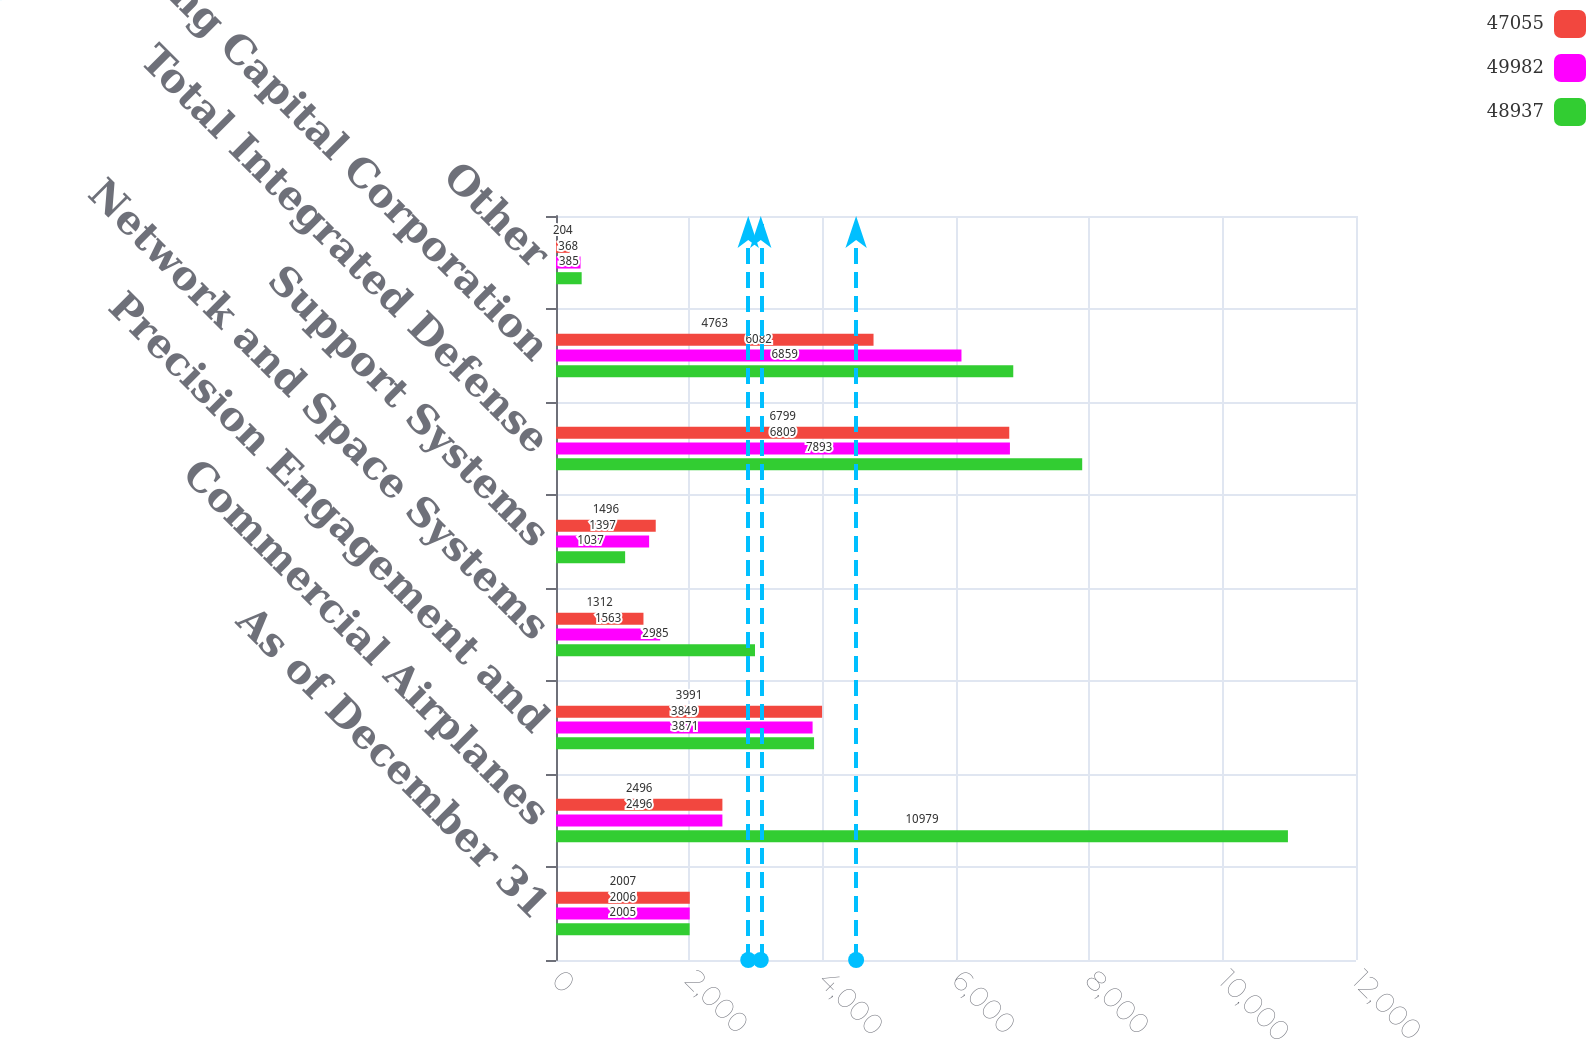<chart> <loc_0><loc_0><loc_500><loc_500><stacked_bar_chart><ecel><fcel>As of December 31<fcel>Commercial Airplanes<fcel>Precision Engagement and<fcel>Network and Space Systems<fcel>Support Systems<fcel>Total Integrated Defense<fcel>Boeing Capital Corporation<fcel>Other<nl><fcel>47055<fcel>2007<fcel>2496<fcel>3991<fcel>1312<fcel>1496<fcel>6799<fcel>4763<fcel>204<nl><fcel>49982<fcel>2006<fcel>2496<fcel>3849<fcel>1563<fcel>1397<fcel>6809<fcel>6082<fcel>368<nl><fcel>48937<fcel>2005<fcel>10979<fcel>3871<fcel>2985<fcel>1037<fcel>7893<fcel>6859<fcel>385<nl></chart> 